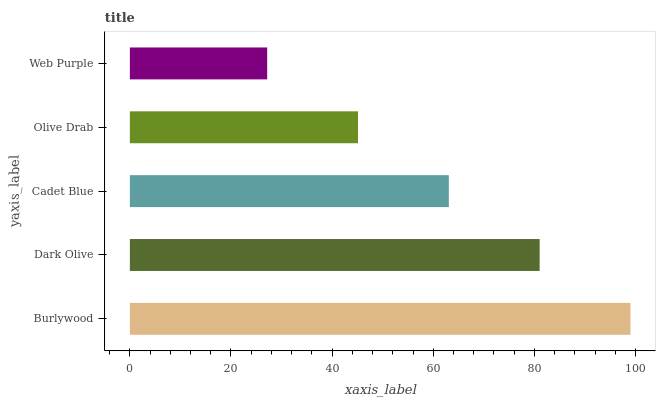Is Web Purple the minimum?
Answer yes or no. Yes. Is Burlywood the maximum?
Answer yes or no. Yes. Is Dark Olive the minimum?
Answer yes or no. No. Is Dark Olive the maximum?
Answer yes or no. No. Is Burlywood greater than Dark Olive?
Answer yes or no. Yes. Is Dark Olive less than Burlywood?
Answer yes or no. Yes. Is Dark Olive greater than Burlywood?
Answer yes or no. No. Is Burlywood less than Dark Olive?
Answer yes or no. No. Is Cadet Blue the high median?
Answer yes or no. Yes. Is Cadet Blue the low median?
Answer yes or no. Yes. Is Olive Drab the high median?
Answer yes or no. No. Is Dark Olive the low median?
Answer yes or no. No. 